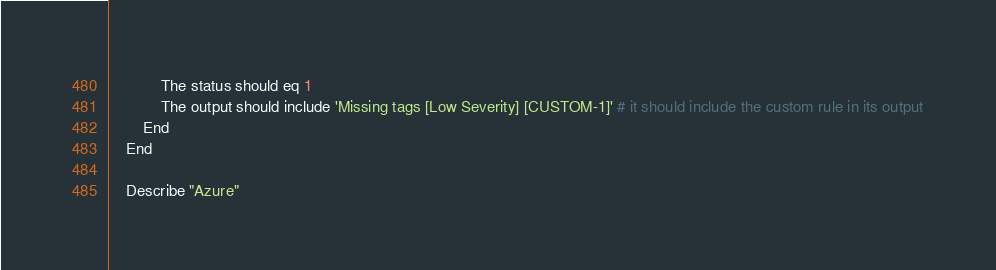Convert code to text. <code><loc_0><loc_0><loc_500><loc_500><_Bash_>            The status should eq 1
            The output should include 'Missing tags [Low Severity] [CUSTOM-1]' # it should include the custom rule in its output
        End
    End

    Describe "Azure"</code> 